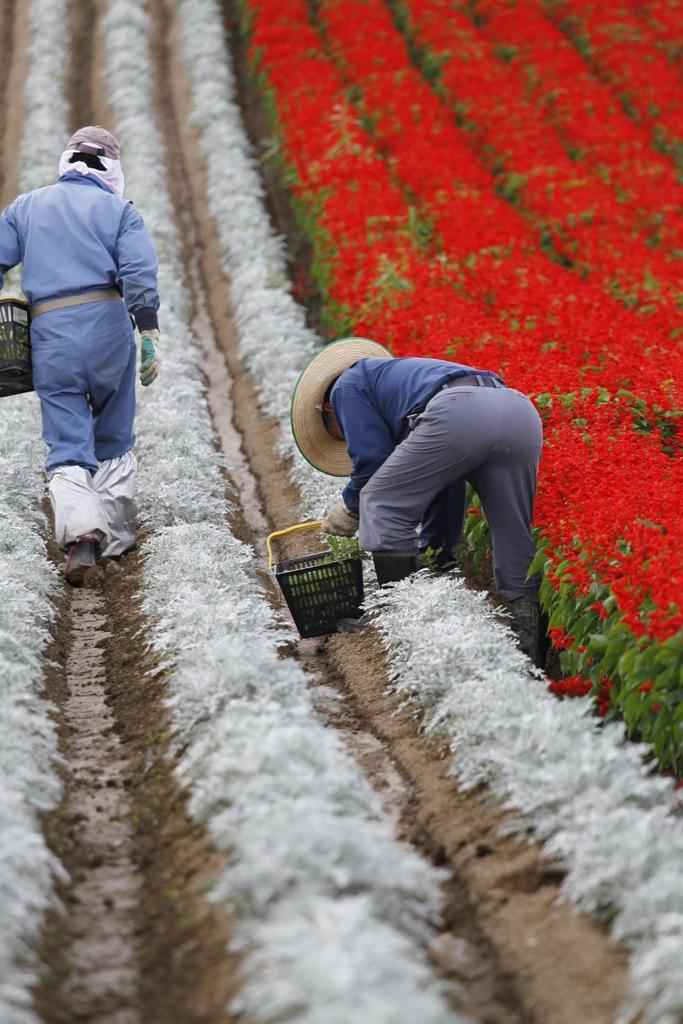What type of living organisms can be seen in the image? Plants can be seen in the image. How many people are present in the image? There are two persons in the image. What are the persons wearing? The persons are wearing clothes. What are the persons holding in their hands? The persons are holding baskets with their hands. What type of stone can be seen in the image? There is no stone present in the image. Are the persons attempting to battle each other in the image? There is no indication of a battle or any attempt to engage in one in the image. 